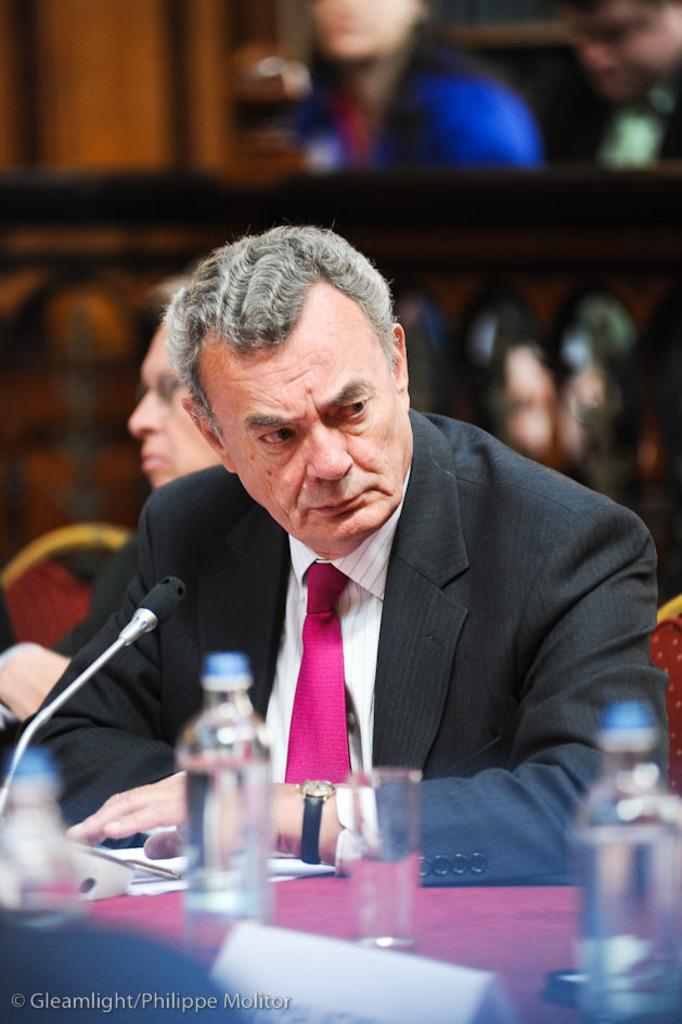What is the person in the image doing? The person is sitting in front of a table. What objects are on the table in the image? There is a glass, a water bottle, and a microphone on the table. Can you describe the background of the image? There are people and a wall in the background of the image. What type of insurance policy is being discussed in the image? There is no indication in the image that an insurance policy is being discussed. 